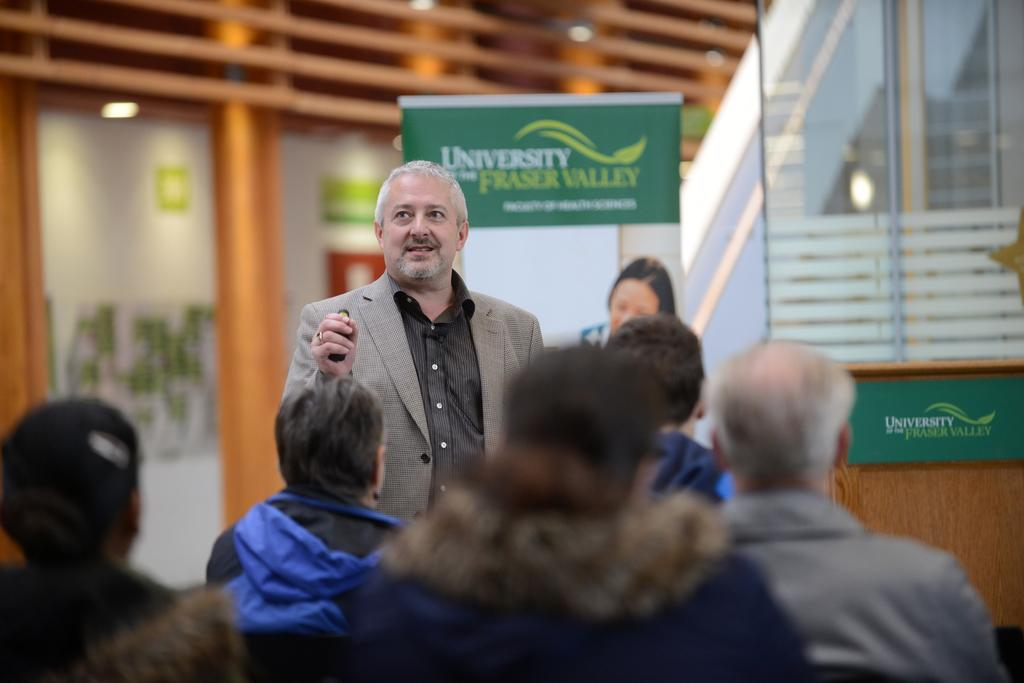What are the people in the image doing? The people in the image are sitting. What is the man in the image doing? The man in the image is standing and holding an object. What can be seen in the background of the image? The background of the image is blurry and includes a banner, a board, glass, and lights. What invention is the man credited for in the image? There is no invention or credit mentioned in the image; it only shows a man standing and holding an object. What is the man trying to get the attention of in the image? There is no indication in the image that the man is trying to get anyone's attention. 